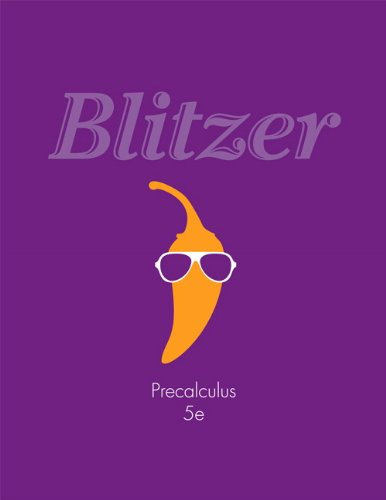Might the book have any additional online resources available for students? Many modern textbooks come with additional online resources, such as interactive quizzes, practice tests, and tutorial videos. While the cover doesn't explicitly mention it, it's quite possible that 'Precalculus (5th Edition)' by Robert F. Blitzer offers supplementary online materials to aid student learning. 